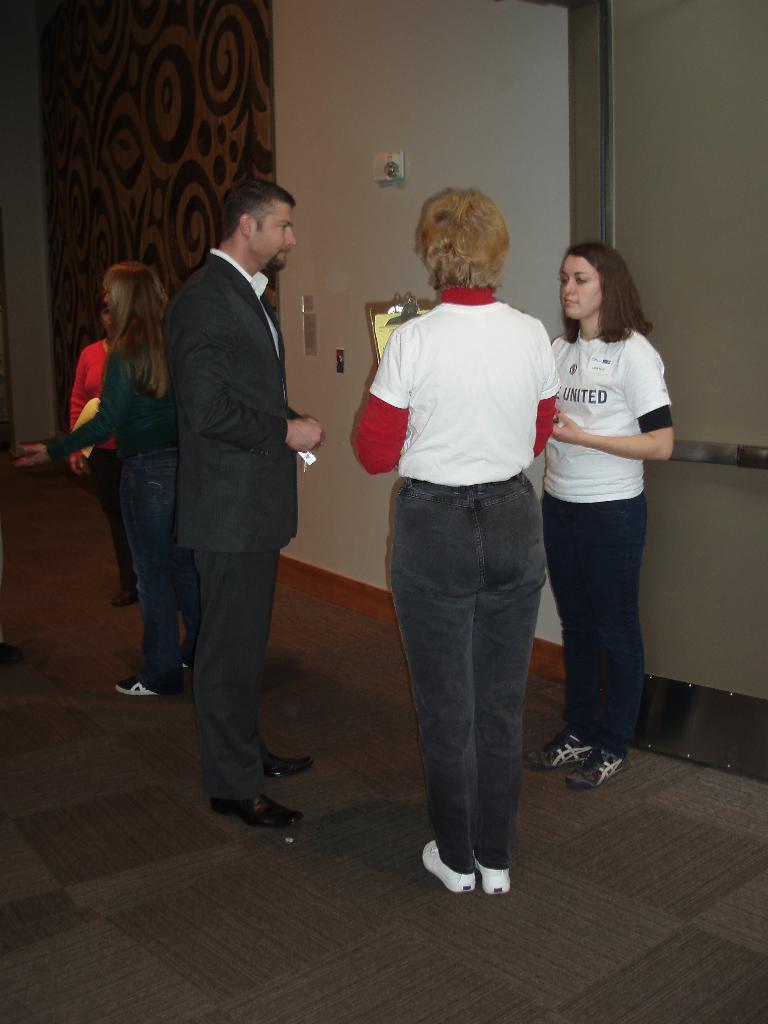Describe this image in one or two sentences. In this image there are people standing on a floor, in the background there is a wall to that wall there is a door and a curtain. 